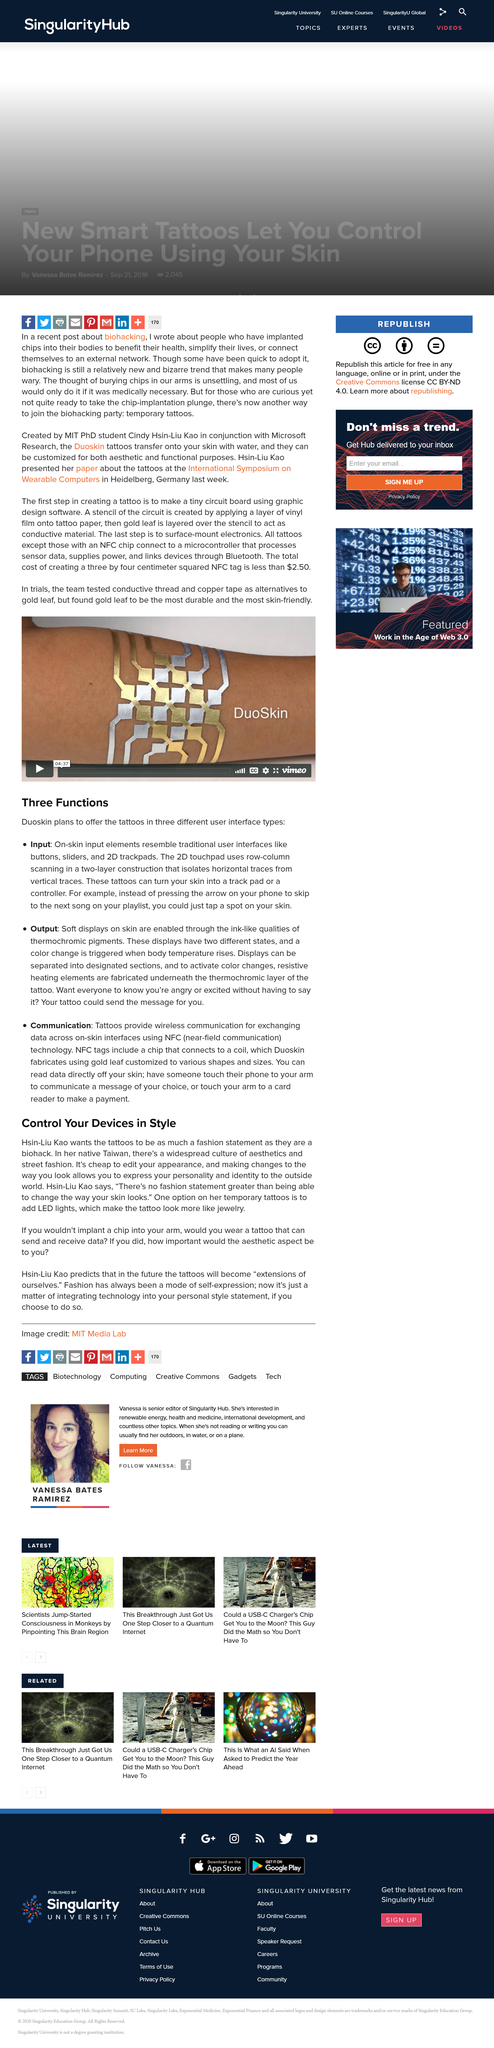Specify some key components in this picture. The input interface type consists of elements that resemble traditional user interfaces, such as buttons, sliders, and 2D trackpads, which allow users to interact with the system by touching the display screen. Input tattoos have the ability to transform your skin into a track pad or controller, providing a unique and innovative means of interacting with technology. Duoskin plans to offer tattoos in three different user interface types, allowing individuals to customize and personalize their skin in a way that is both functional and aesthetically pleasing. The title of this article is 'Control Your Devices in Style'. Hsin's native culture is Taiwanese. 